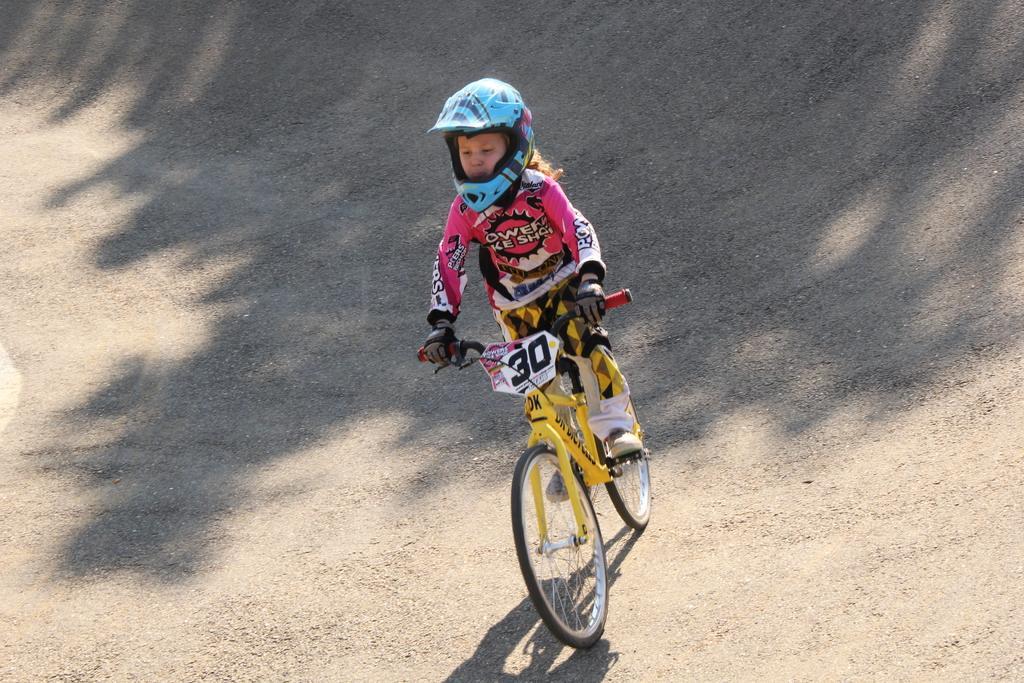How would you summarize this image in a sentence or two? In this image, we can see a kid riding a bicycle. We can see the ground with some shadow. 